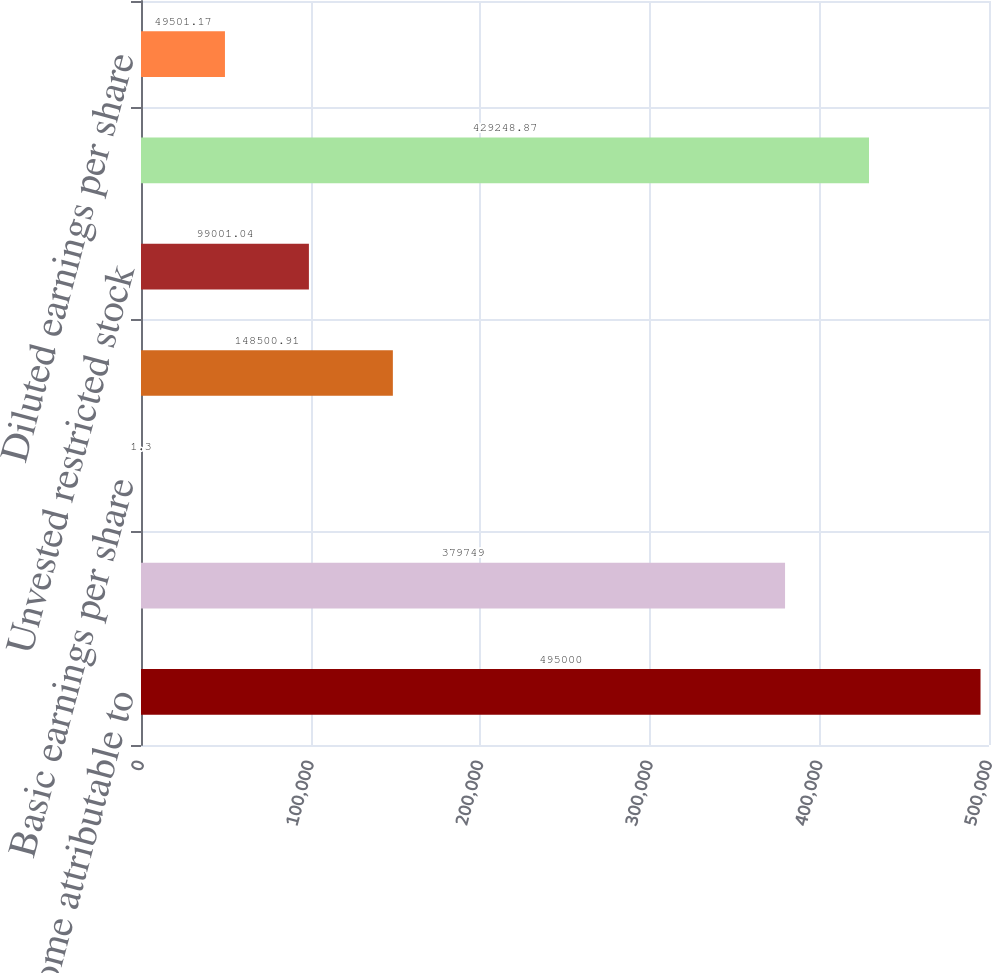Convert chart to OTSL. <chart><loc_0><loc_0><loc_500><loc_500><bar_chart><fcel>Net income attributable to<fcel>Weighted average common shares<fcel>Basic earnings per share<fcel>Options to purchase common<fcel>Unvested restricted stock<fcel>Weighted average common and<fcel>Diluted earnings per share<nl><fcel>495000<fcel>379749<fcel>1.3<fcel>148501<fcel>99001<fcel>429249<fcel>49501.2<nl></chart> 